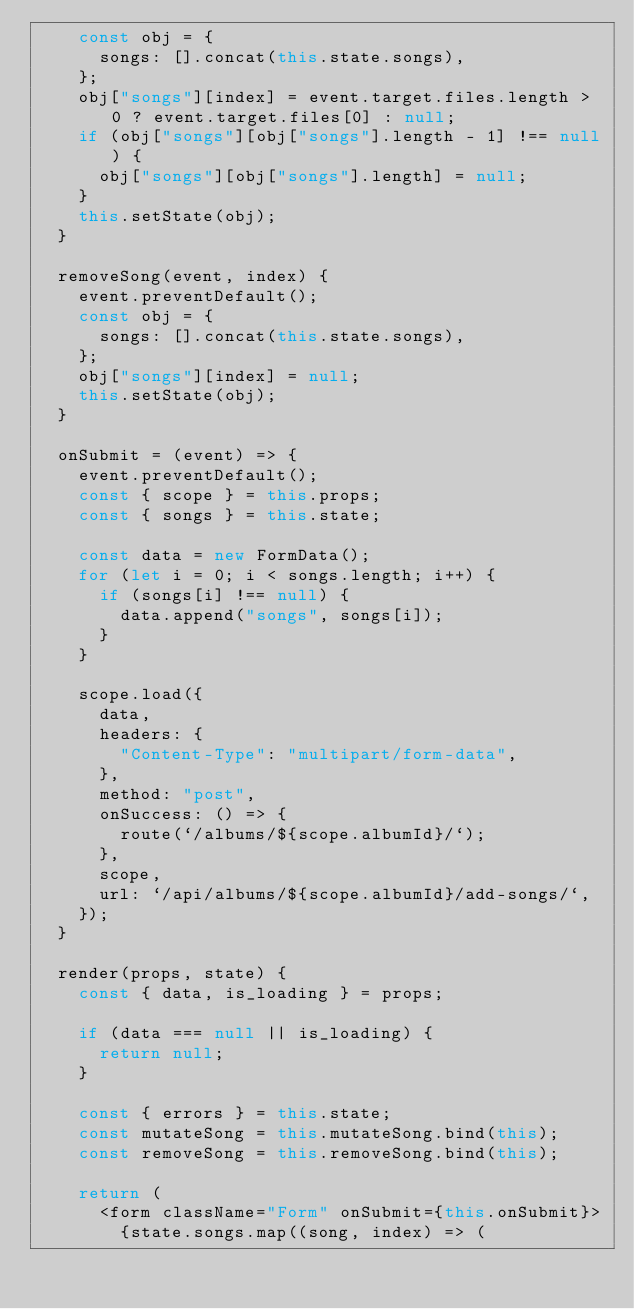<code> <loc_0><loc_0><loc_500><loc_500><_JavaScript_>    const obj = {
      songs: [].concat(this.state.songs),
    };
    obj["songs"][index] = event.target.files.length > 0 ? event.target.files[0] : null;
    if (obj["songs"][obj["songs"].length - 1] !== null) {
      obj["songs"][obj["songs"].length] = null;
    }
    this.setState(obj);
  }

  removeSong(event, index) {
    event.preventDefault();
    const obj = {
      songs: [].concat(this.state.songs),
    };
    obj["songs"][index] = null;
    this.setState(obj);
  }

  onSubmit = (event) => {
    event.preventDefault();
    const { scope } = this.props;
    const { songs } = this.state;

    const data = new FormData();
    for (let i = 0; i < songs.length; i++) {
      if (songs[i] !== null) {
        data.append("songs", songs[i]);
      }
    }

    scope.load({
      data,
      headers: {
        "Content-Type": "multipart/form-data",
      },
      method: "post",
      onSuccess: () => {
        route(`/albums/${scope.albumId}/`);
      },
      scope,
      url: `/api/albums/${scope.albumId}/add-songs/`,
    });
  }

  render(props, state) {
    const { data, is_loading } = props;

    if (data === null || is_loading) {
      return null;
    }

    const { errors } = this.state;
    const mutateSong = this.mutateSong.bind(this);
    const removeSong = this.removeSong.bind(this);

    return (
      <form className="Form" onSubmit={this.onSubmit}>
        {state.songs.map((song, index) => (</code> 